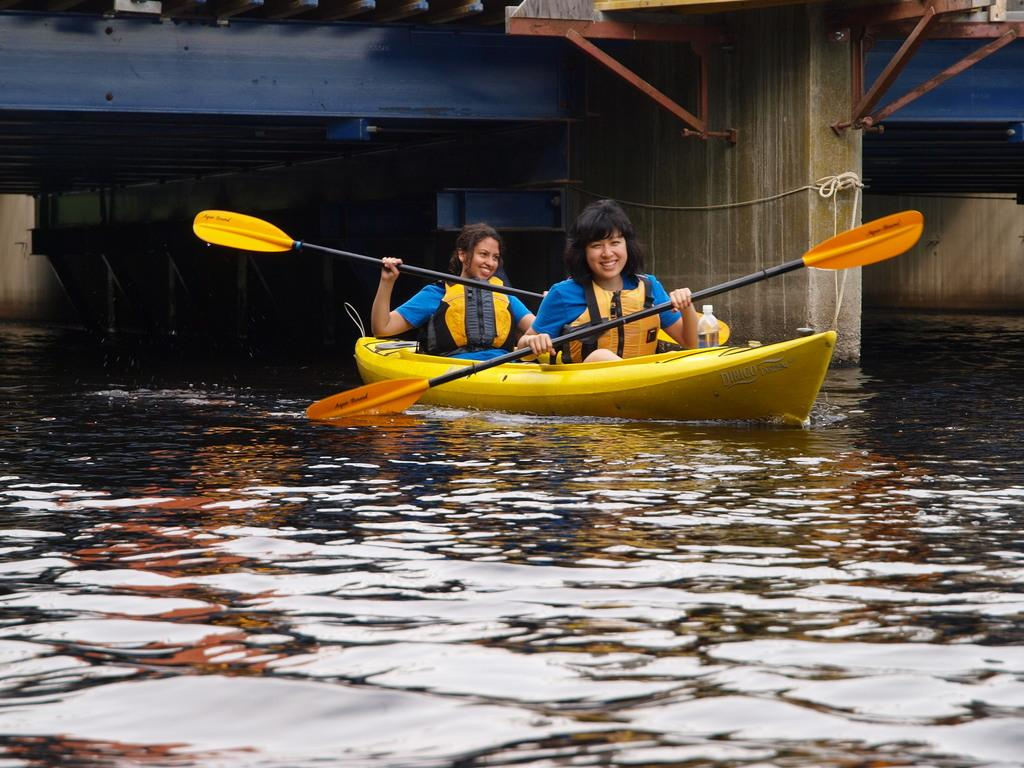How many people are in the boat in the image? There are two people in the boat in the image. What are the people doing in the boat? The people are holding paddles in the image. Where is the boat located? The boat is on water in the image. What can be seen in the background of the image? There is a bridge visible in the background. What color are the ghosts in the image? There are no ghosts present in the image. How many kittens are sitting on the boat in the image? There are no kittens present in the image. 